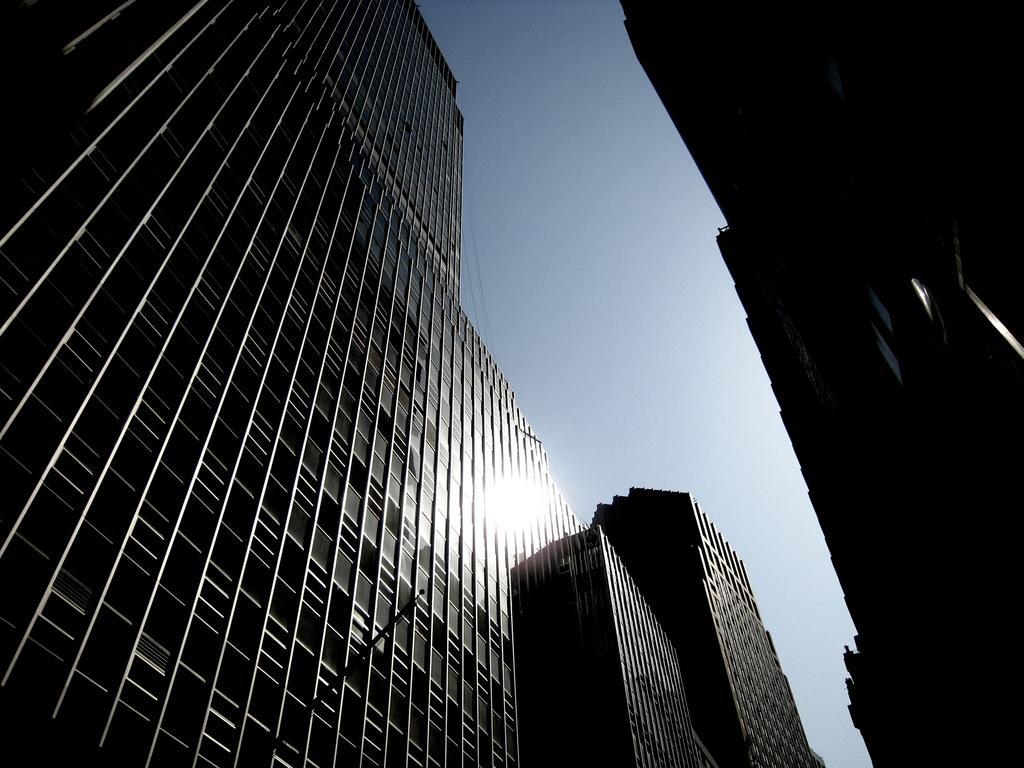Describe this image in one or two sentences. In this image I can see buildings and the sky. This image is taken may be during a day. 